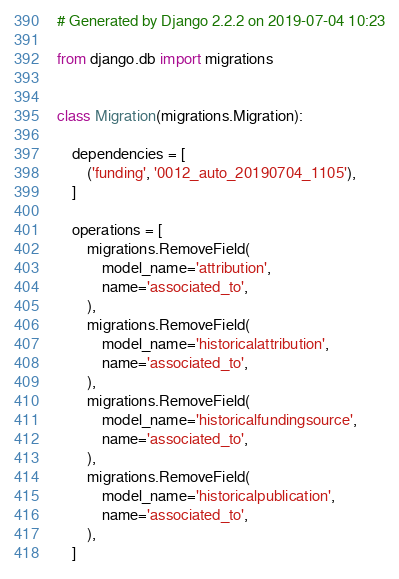Convert code to text. <code><loc_0><loc_0><loc_500><loc_500><_Python_># Generated by Django 2.2.2 on 2019-07-04 10:23

from django.db import migrations


class Migration(migrations.Migration):

    dependencies = [
        ('funding', '0012_auto_20190704_1105'),
    ]

    operations = [
        migrations.RemoveField(
            model_name='attribution',
            name='associated_to',
        ),
        migrations.RemoveField(
            model_name='historicalattribution',
            name='associated_to',
        ),
        migrations.RemoveField(
            model_name='historicalfundingsource',
            name='associated_to',
        ),
        migrations.RemoveField(
            model_name='historicalpublication',
            name='associated_to',
        ),
    ]
</code> 